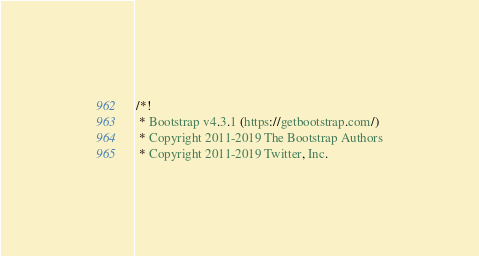Convert code to text. <code><loc_0><loc_0><loc_500><loc_500><_CSS_>/*!
 * Bootstrap v4.3.1 (https://getbootstrap.com/)
 * Copyright 2011-2019 The Bootstrap Authors
 * Copyright 2011-2019 Twitter, Inc.</code> 